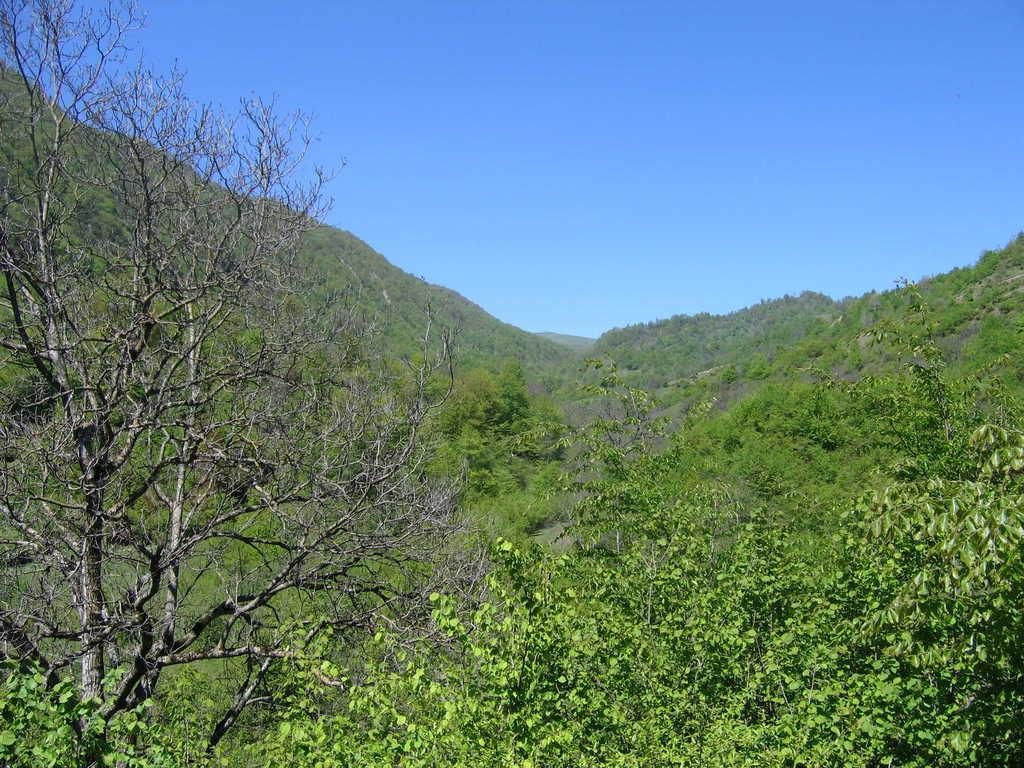What type of vegetation can be seen in the image? There are trees in the image. What type of geographical feature is present in the image? There are hills in the image. What is visible in the background of the image? The sky is visible in the background of the image, and it is described as blue. What type of show can be seen happening on the hills in the image? There is no show or event happening on the hills in the image; it features trees and hills with a blue sky in the background. What type of feeling can be seen expressed on the trees in the image? Trees do not express feelings, as they are inanimate objects. 